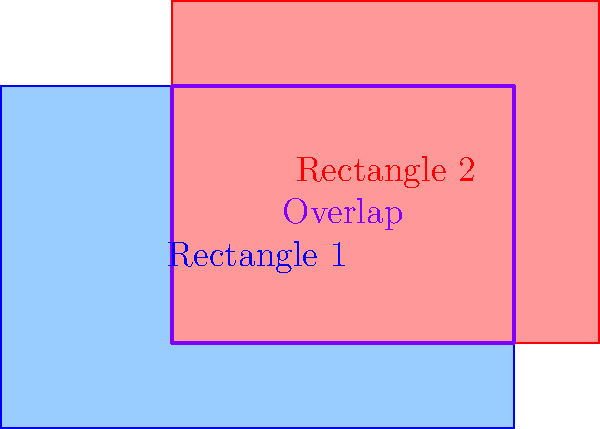Given two rectangles in a 2D coordinate system:
Rectangle 1: Bottom-left corner at $(0,0)$, top-right corner at $(6,4)$
Rectangle 2: Bottom-left corner at $(2,1)$, top-right corner at $(7,5)$

Calculate the area of the overlapping region between these two rectangles. To find the area of overlap between two rectangles, we need to follow these steps:

1. Determine the coordinates of the overlapping region:
   - Left edge: $max(0, 2) = 2$
   - Bottom edge: $max(0, 1) = 1$
   - Right edge: $min(6, 7) = 6$
   - Top edge: $min(4, 5) = 4$

2. Calculate the width and height of the overlapping region:
   - Width = Right edge - Left edge = $6 - 2 = 4$
   - Height = Top edge - Bottom edge = $4 - 1 = 3$

3. Compute the area of the overlapping region:
   Area = Width * Height = $4 * 3 = 12$

Therefore, the area of the overlapping region is 12 square units.
Answer: $12$ square units 